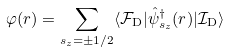Convert formula to latex. <formula><loc_0><loc_0><loc_500><loc_500>\varphi ( r ) = \sum _ { s _ { z } = \pm 1 / 2 } \langle \mathcal { F } _ { \mathrm D } | \hat { \psi } ^ { \dagger } _ { s _ { z } } ( r ) | \mathcal { I } _ { \mathrm D } \rangle</formula> 